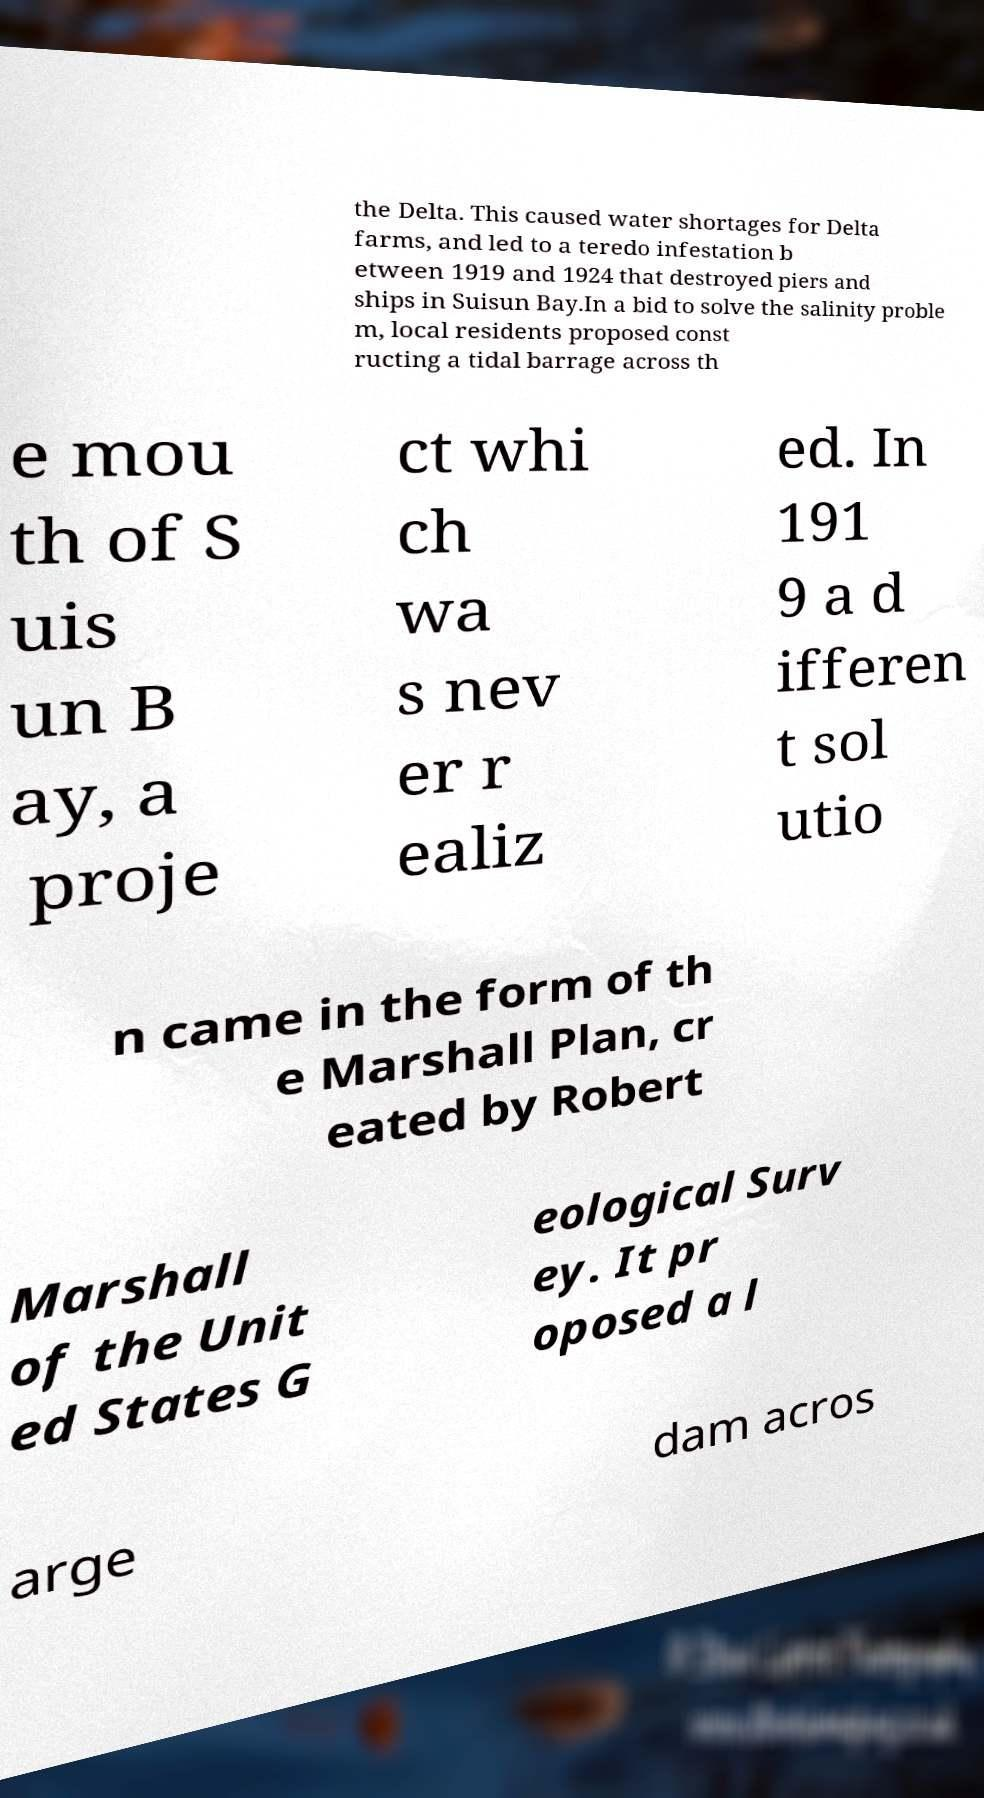Can you accurately transcribe the text from the provided image for me? the Delta. This caused water shortages for Delta farms, and led to a teredo infestation b etween 1919 and 1924 that destroyed piers and ships in Suisun Bay.In a bid to solve the salinity proble m, local residents proposed const ructing a tidal barrage across th e mou th of S uis un B ay, a proje ct whi ch wa s nev er r ealiz ed. In 191 9 a d ifferen t sol utio n came in the form of th e Marshall Plan, cr eated by Robert Marshall of the Unit ed States G eological Surv ey. It pr oposed a l arge dam acros 